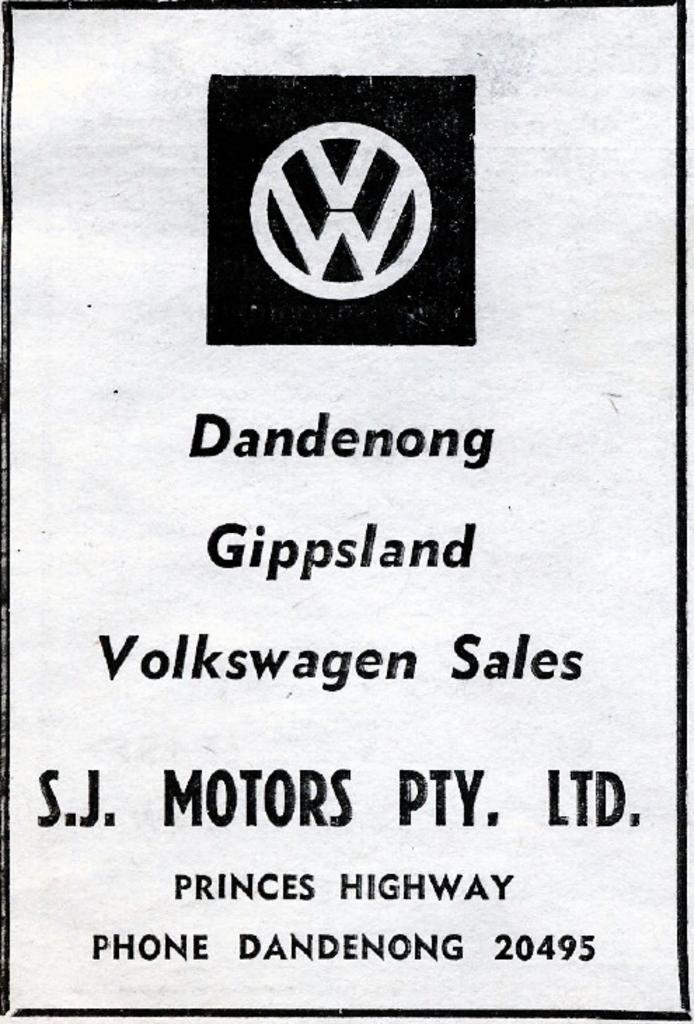<image>
Share a concise interpretation of the image provided. A flyer for Volkswagen sales by S.J. MOTORS PTY. LTD. 